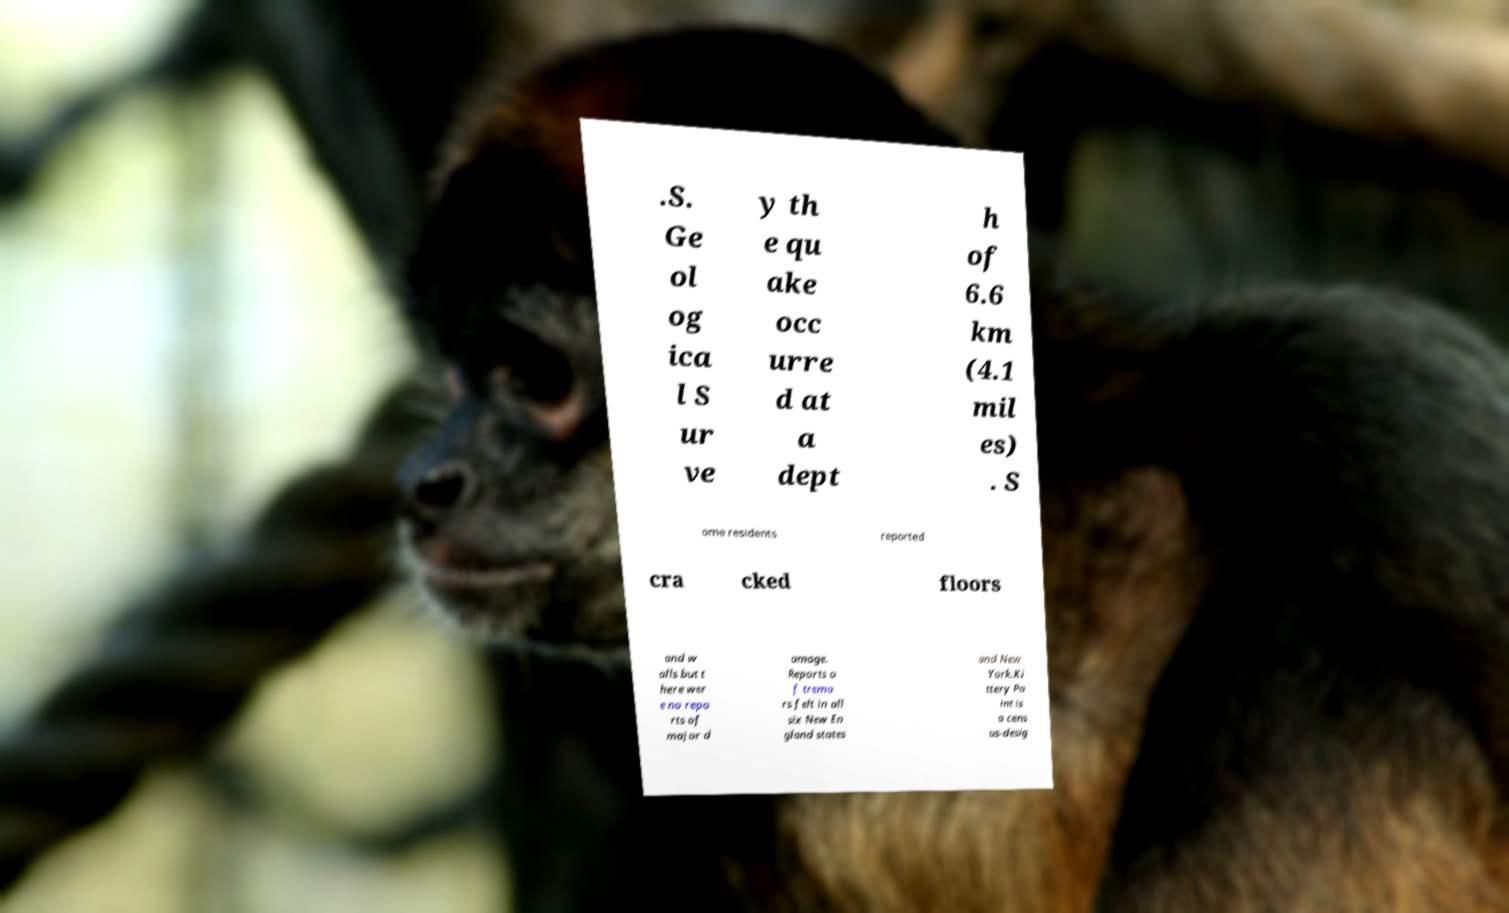I need the written content from this picture converted into text. Can you do that? .S. Ge ol og ica l S ur ve y th e qu ake occ urre d at a dept h of 6.6 km (4.1 mil es) . S ome residents reported cra cked floors and w alls but t here wer e no repo rts of major d amage. Reports o f tremo rs felt in all six New En gland states and New York.Ki ttery Po int is a cens us-desig 